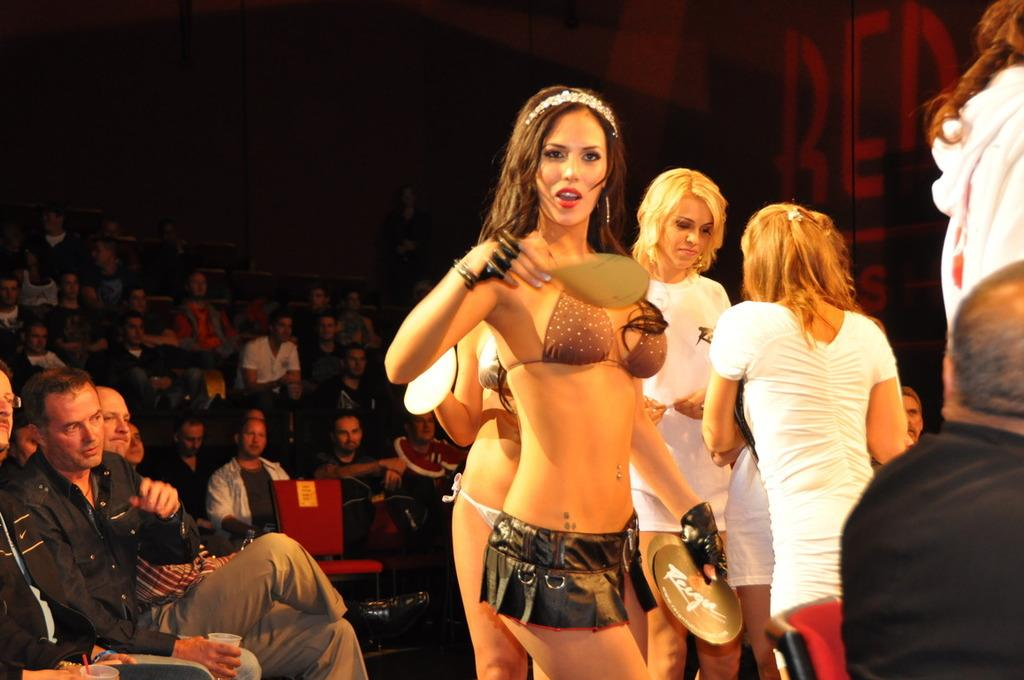What is happening on the left side of the image? There is a group of people sitting on chairs on the left side of the image. What is happening on the right side of the image? There are girls standing on the right side of the image. Can you describe the clothing of some of the girls? Some of the girls are wearing t-shirts. What type of route can be seen in the image? There is no route visible in the image; it features a group of people sitting on chairs and girls standing nearby. Can you tell me how many goats are present in the image? There are no goats present in the image. 